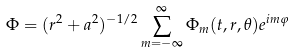<formula> <loc_0><loc_0><loc_500><loc_500>\Phi = ( r ^ { 2 } + a ^ { 2 } ) ^ { - 1 / 2 } \sum _ { m = - \infty } ^ { \infty } \Phi _ { m } ( t , r , \theta ) e ^ { i m \varphi }</formula> 